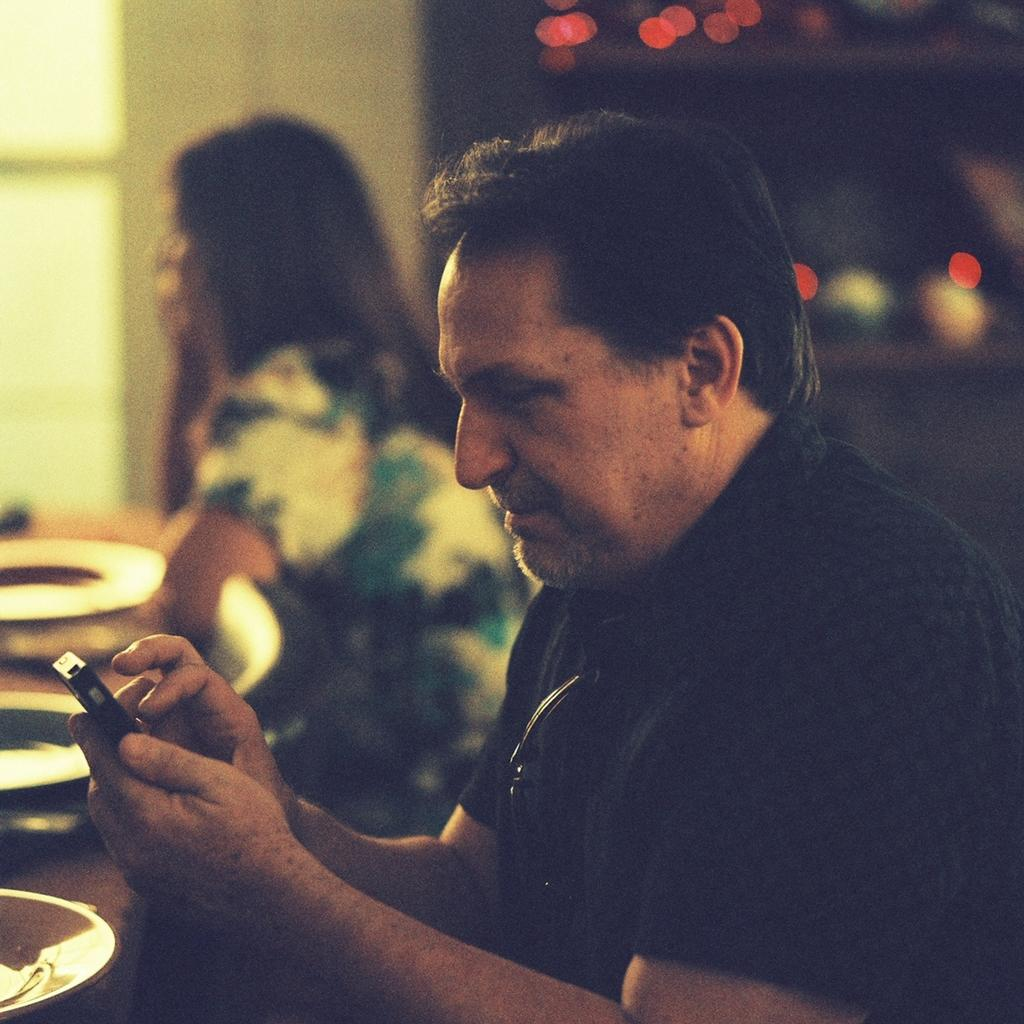Who can be seen in the image? There is a woman and a man in the image. What are the woman and the man doing in the image? Both the woman and the man are sitting on chairs. What is present in front of them? There is a table in front of them. What is on the table? There are plates on the table. Can you describe the background of the image? The background of the image is blurred. What type of harmony is being played on the wrench in the image? There is no wrench present in the image, and therefore no music or harmony can be observed. 